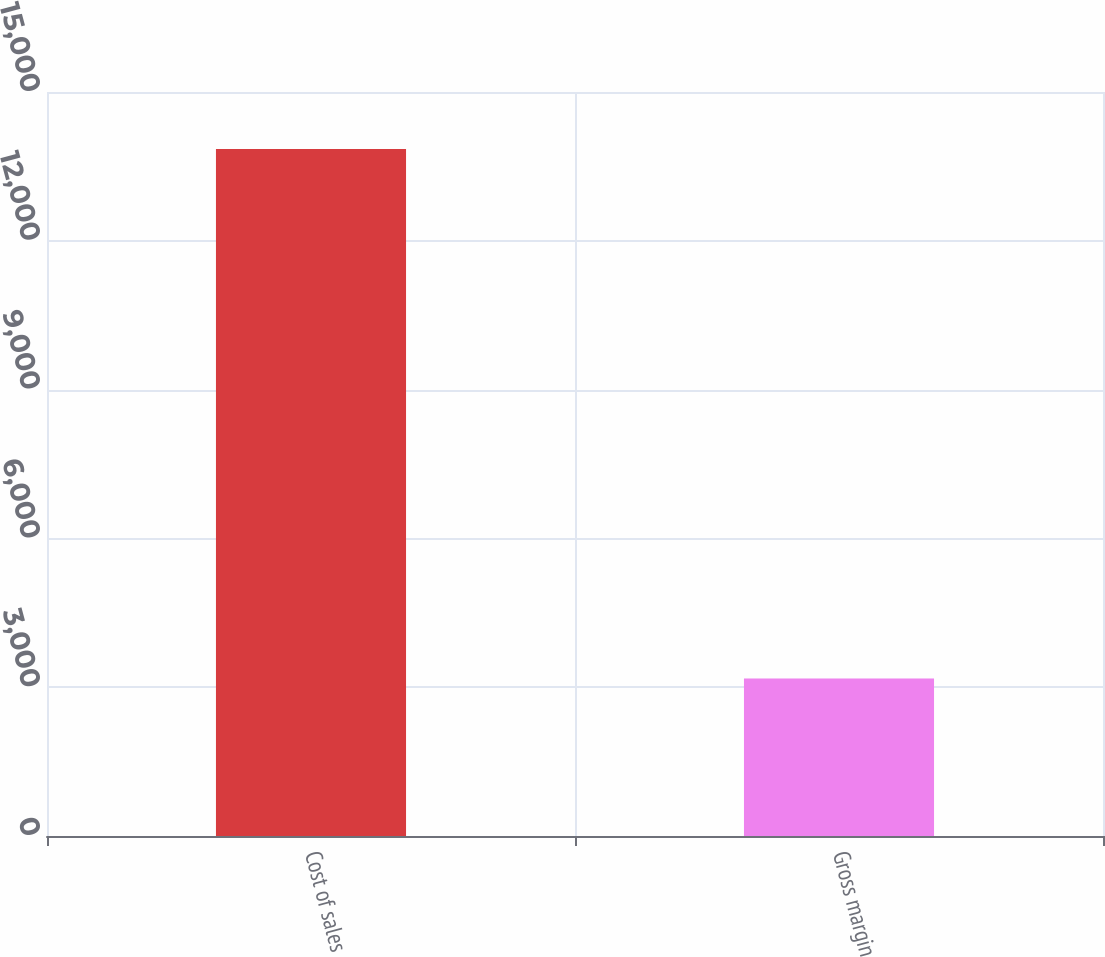Convert chart. <chart><loc_0><loc_0><loc_500><loc_500><bar_chart><fcel>Cost of sales<fcel>Gross margin<nl><fcel>13850<fcel>3173<nl></chart> 